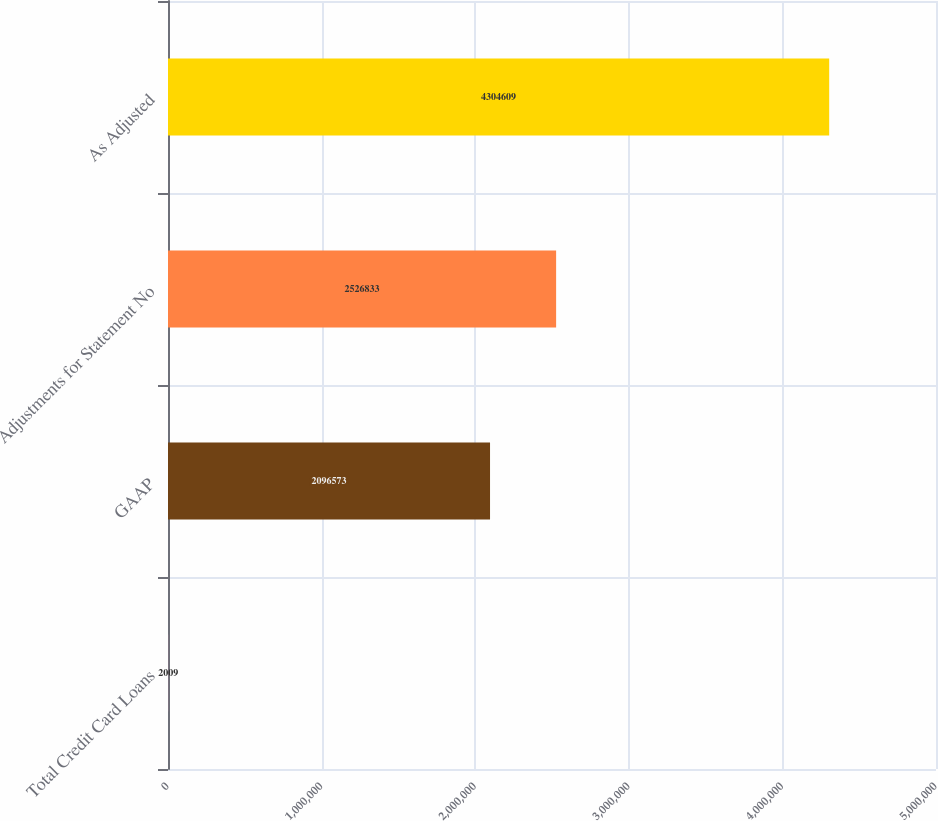Convert chart. <chart><loc_0><loc_0><loc_500><loc_500><bar_chart><fcel>Total Credit Card Loans<fcel>GAAP<fcel>Adjustments for Statement No<fcel>As Adjusted<nl><fcel>2009<fcel>2.09657e+06<fcel>2.52683e+06<fcel>4.30461e+06<nl></chart> 